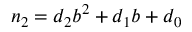Convert formula to latex. <formula><loc_0><loc_0><loc_500><loc_500>n _ { 2 } = d _ { 2 } b ^ { 2 } + d _ { 1 } b + d _ { 0 }</formula> 